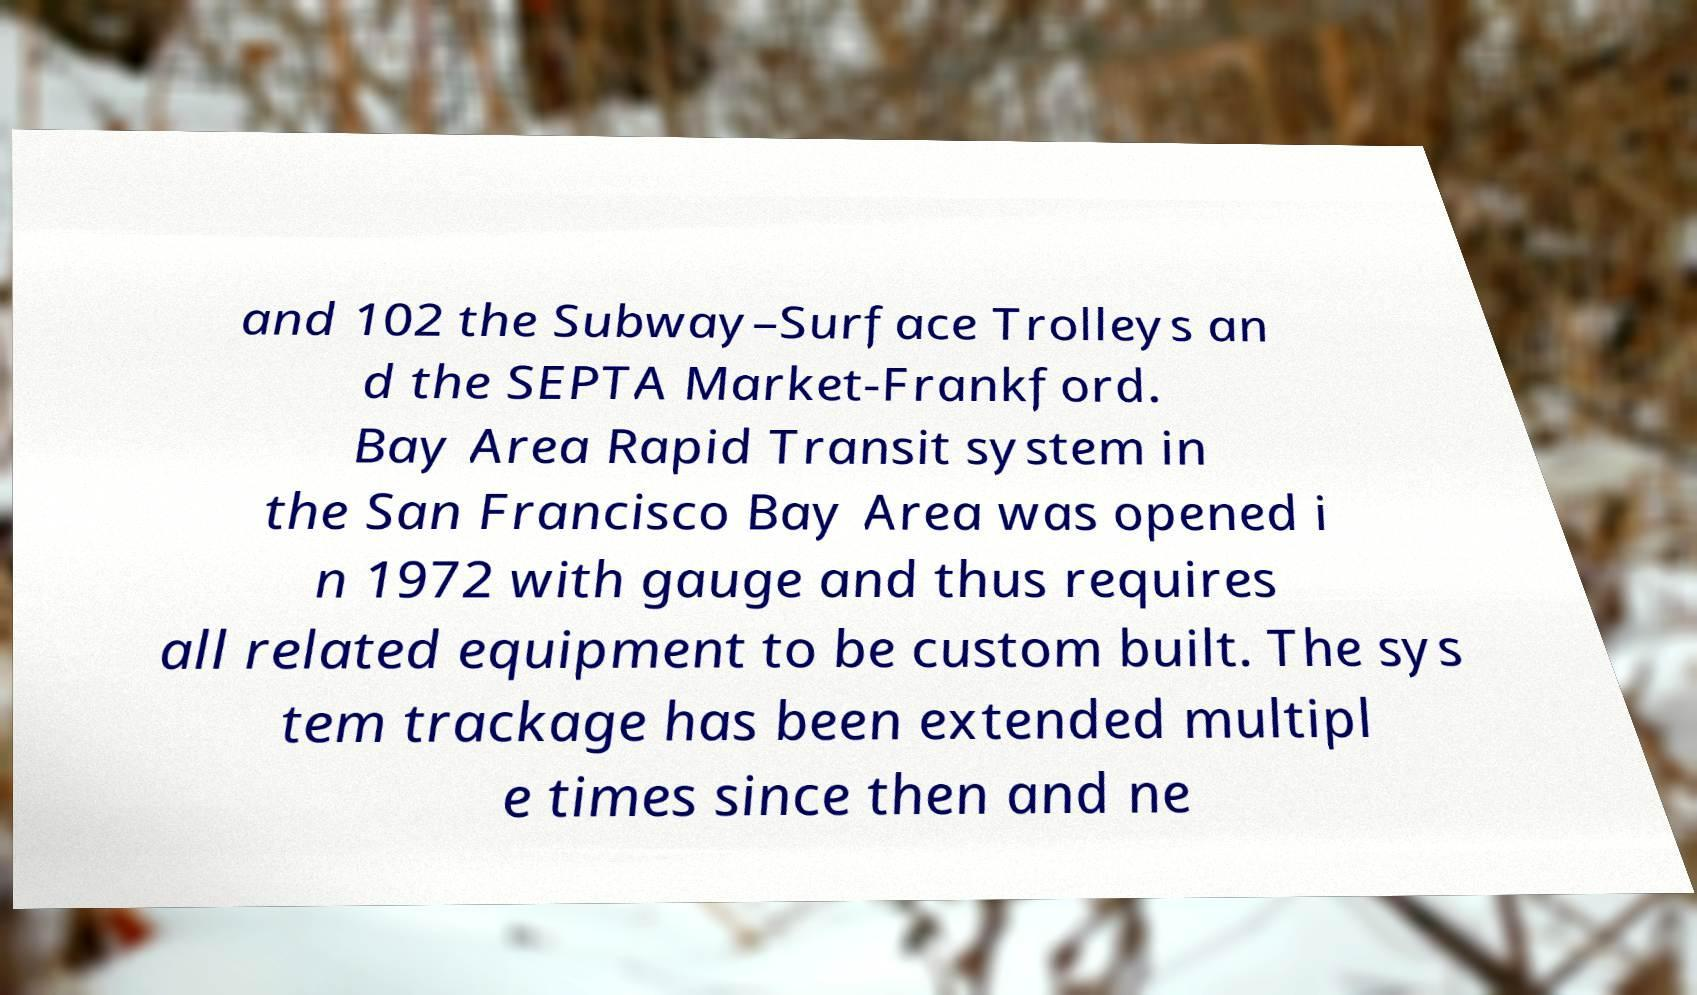Please read and relay the text visible in this image. What does it say? and 102 the Subway–Surface Trolleys an d the SEPTA Market-Frankford. Bay Area Rapid Transit system in the San Francisco Bay Area was opened i n 1972 with gauge and thus requires all related equipment to be custom built. The sys tem trackage has been extended multipl e times since then and ne 